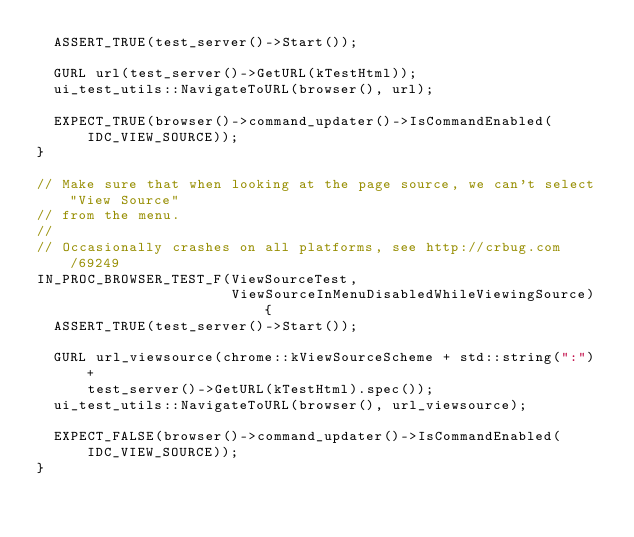<code> <loc_0><loc_0><loc_500><loc_500><_C++_>  ASSERT_TRUE(test_server()->Start());

  GURL url(test_server()->GetURL(kTestHtml));
  ui_test_utils::NavigateToURL(browser(), url);

  EXPECT_TRUE(browser()->command_updater()->IsCommandEnabled(IDC_VIEW_SOURCE));
}

// Make sure that when looking at the page source, we can't select "View Source"
// from the menu.
//
// Occasionally crashes on all platforms, see http://crbug.com/69249
IN_PROC_BROWSER_TEST_F(ViewSourceTest,
                       ViewSourceInMenuDisabledWhileViewingSource) {
  ASSERT_TRUE(test_server()->Start());

  GURL url_viewsource(chrome::kViewSourceScheme + std::string(":") +
      test_server()->GetURL(kTestHtml).spec());
  ui_test_utils::NavigateToURL(browser(), url_viewsource);

  EXPECT_FALSE(browser()->command_updater()->IsCommandEnabled(IDC_VIEW_SOURCE));
}
</code> 